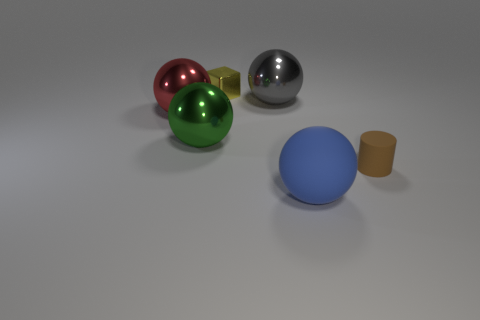How would you describe the lighting in this scene? The lighting in the scene is soft and diffused, with subtle shadows indicating a light source overhead, possibly intended to mimic natural lighting conditions and highlight the shapes and materials of the objects. 